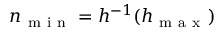<formula> <loc_0><loc_0><loc_500><loc_500>n _ { m i n } = h ^ { - 1 } ( h _ { m a x } )</formula> 